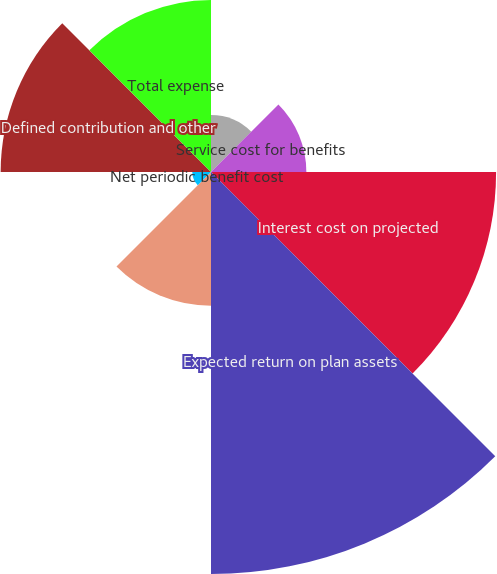Convert chart to OTSL. <chart><loc_0><loc_0><loc_500><loc_500><pie_chart><fcel>(DOLLARS IN THOUSANDS)<fcel>Service cost for benefits<fcel>Interest cost on projected<fcel>Expected return on plan assets<fcel>Net amortization of deferrals<fcel>Net periodic benefit cost<fcel>Defined contribution and other<fcel>Total expense<nl><fcel>4.15%<fcel>6.94%<fcel>20.75%<fcel>29.26%<fcel>9.73%<fcel>1.36%<fcel>15.31%<fcel>12.52%<nl></chart> 